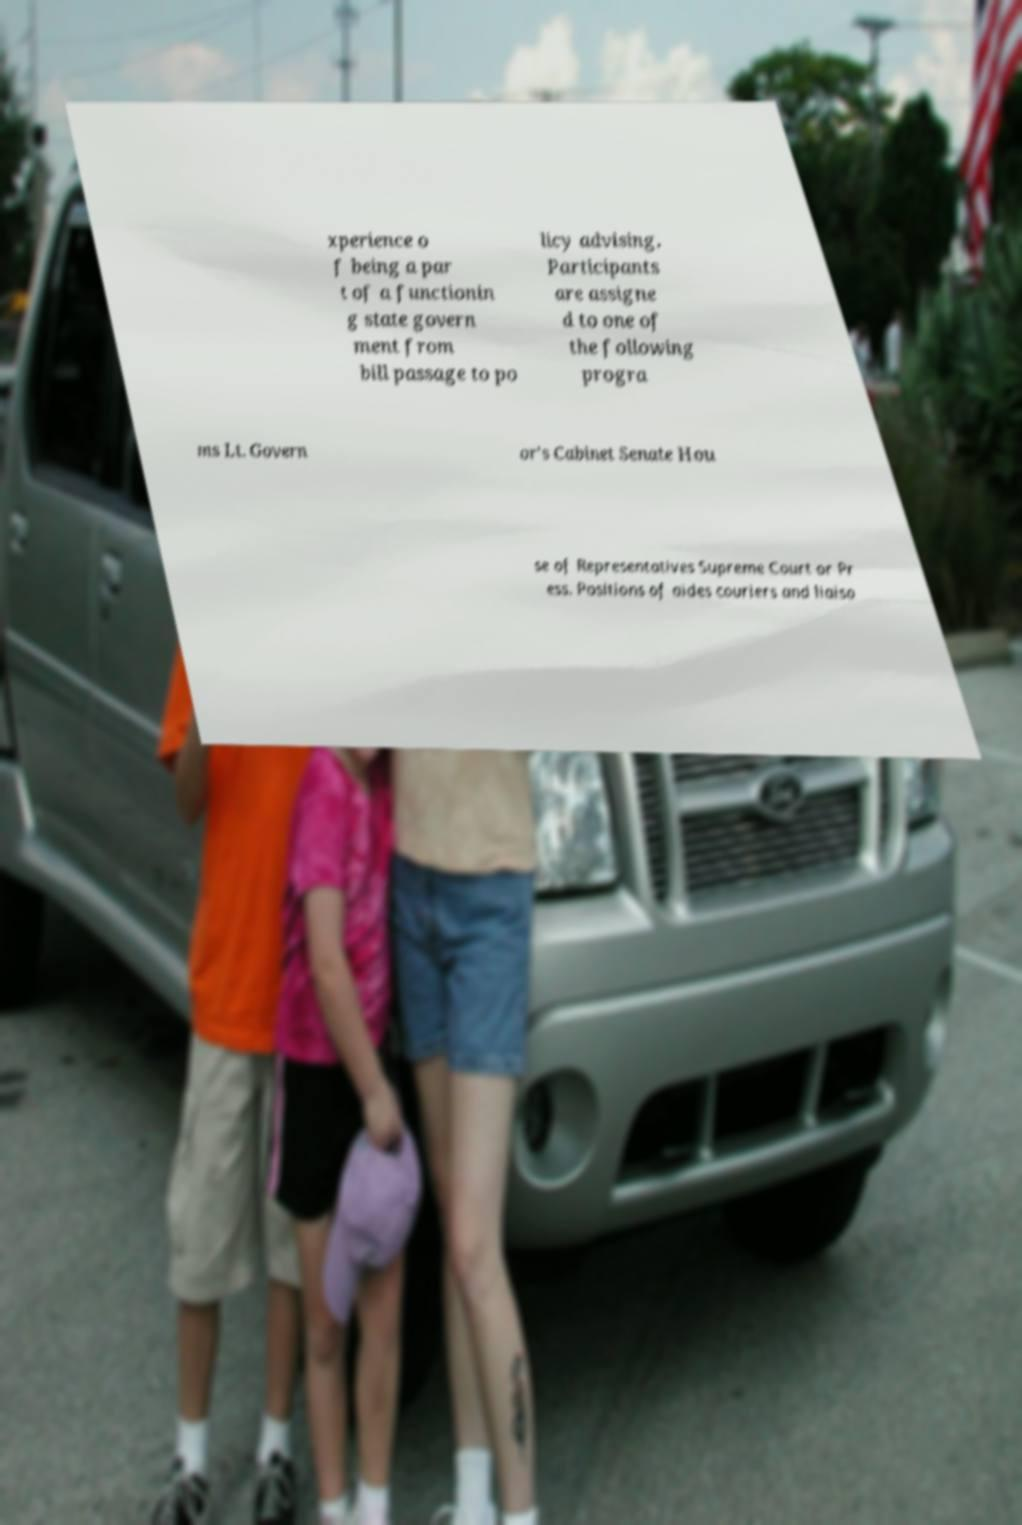Can you accurately transcribe the text from the provided image for me? xperience o f being a par t of a functionin g state govern ment from bill passage to po licy advising. Participants are assigne d to one of the following progra ms Lt. Govern or's Cabinet Senate Hou se of Representatives Supreme Court or Pr ess. Positions of aides couriers and liaiso 